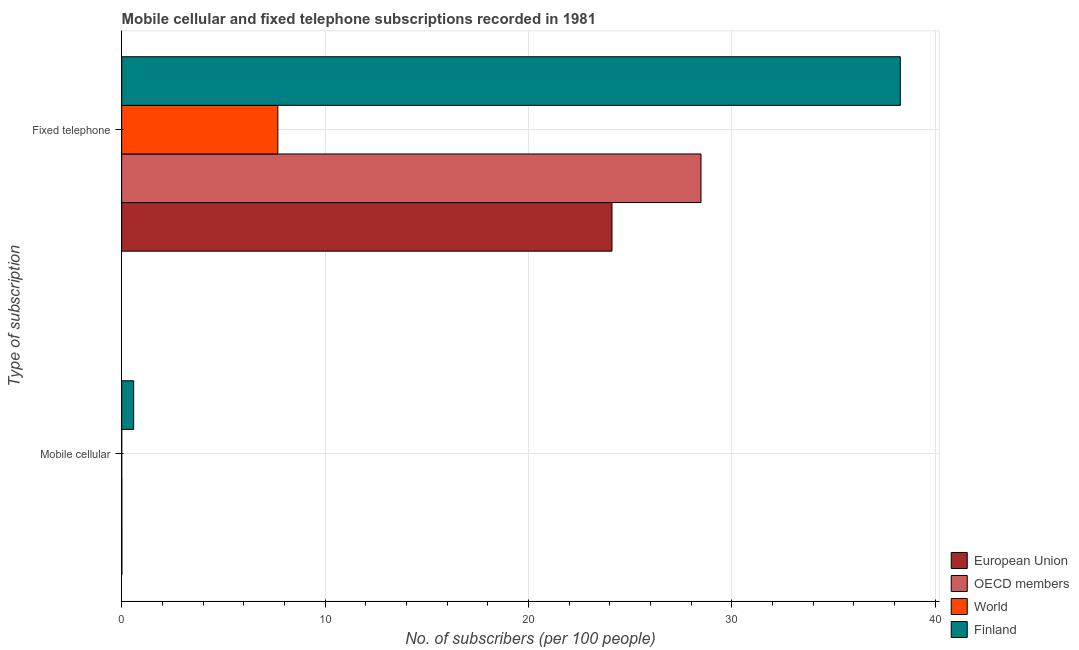How many different coloured bars are there?
Offer a very short reply. 4. Are the number of bars per tick equal to the number of legend labels?
Ensure brevity in your answer.  Yes. How many bars are there on the 2nd tick from the top?
Your answer should be compact. 4. What is the label of the 1st group of bars from the top?
Keep it short and to the point. Fixed telephone. What is the number of mobile cellular subscribers in World?
Your response must be concise. 0. Across all countries, what is the maximum number of fixed telephone subscribers?
Give a very brief answer. 38.28. Across all countries, what is the minimum number of fixed telephone subscribers?
Provide a succinct answer. 7.68. In which country was the number of mobile cellular subscribers minimum?
Your answer should be very brief. World. What is the total number of mobile cellular subscribers in the graph?
Provide a short and direct response. 0.61. What is the difference between the number of mobile cellular subscribers in European Union and that in World?
Offer a very short reply. 0.01. What is the difference between the number of fixed telephone subscribers in World and the number of mobile cellular subscribers in European Union?
Offer a very short reply. 7.67. What is the average number of fixed telephone subscribers per country?
Your answer should be very brief. 24.64. What is the difference between the number of fixed telephone subscribers and number of mobile cellular subscribers in OECD members?
Your response must be concise. 28.48. In how many countries, is the number of fixed telephone subscribers greater than 28 ?
Ensure brevity in your answer.  2. What is the ratio of the number of mobile cellular subscribers in OECD members to that in European Union?
Provide a short and direct response. 0.8. Is the number of mobile cellular subscribers in World less than that in OECD members?
Offer a very short reply. Yes. What does the 1st bar from the bottom in Mobile cellular represents?
Offer a terse response. European Union. What is the difference between two consecutive major ticks on the X-axis?
Give a very brief answer. 10. Does the graph contain any zero values?
Make the answer very short. No. Where does the legend appear in the graph?
Offer a very short reply. Bottom right. How many legend labels are there?
Provide a short and direct response. 4. What is the title of the graph?
Provide a succinct answer. Mobile cellular and fixed telephone subscriptions recorded in 1981. What is the label or title of the X-axis?
Your answer should be very brief. No. of subscribers (per 100 people). What is the label or title of the Y-axis?
Provide a succinct answer. Type of subscription. What is the No. of subscribers (per 100 people) of European Union in Mobile cellular?
Your response must be concise. 0.01. What is the No. of subscribers (per 100 people) of OECD members in Mobile cellular?
Offer a terse response. 0.01. What is the No. of subscribers (per 100 people) of World in Mobile cellular?
Your response must be concise. 0. What is the No. of subscribers (per 100 people) of Finland in Mobile cellular?
Provide a short and direct response. 0.59. What is the No. of subscribers (per 100 people) of European Union in Fixed telephone?
Make the answer very short. 24.11. What is the No. of subscribers (per 100 people) in OECD members in Fixed telephone?
Give a very brief answer. 28.48. What is the No. of subscribers (per 100 people) of World in Fixed telephone?
Provide a succinct answer. 7.68. What is the No. of subscribers (per 100 people) of Finland in Fixed telephone?
Your answer should be compact. 38.28. Across all Type of subscription, what is the maximum No. of subscribers (per 100 people) in European Union?
Your response must be concise. 24.11. Across all Type of subscription, what is the maximum No. of subscribers (per 100 people) in OECD members?
Provide a short and direct response. 28.48. Across all Type of subscription, what is the maximum No. of subscribers (per 100 people) of World?
Your response must be concise. 7.68. Across all Type of subscription, what is the maximum No. of subscribers (per 100 people) of Finland?
Provide a short and direct response. 38.28. Across all Type of subscription, what is the minimum No. of subscribers (per 100 people) of European Union?
Offer a very short reply. 0.01. Across all Type of subscription, what is the minimum No. of subscribers (per 100 people) in OECD members?
Your response must be concise. 0.01. Across all Type of subscription, what is the minimum No. of subscribers (per 100 people) in World?
Offer a terse response. 0. Across all Type of subscription, what is the minimum No. of subscribers (per 100 people) in Finland?
Give a very brief answer. 0.59. What is the total No. of subscribers (per 100 people) of European Union in the graph?
Your response must be concise. 24.12. What is the total No. of subscribers (per 100 people) of OECD members in the graph?
Make the answer very short. 28.49. What is the total No. of subscribers (per 100 people) in World in the graph?
Your response must be concise. 7.68. What is the total No. of subscribers (per 100 people) in Finland in the graph?
Offer a terse response. 38.87. What is the difference between the No. of subscribers (per 100 people) in European Union in Mobile cellular and that in Fixed telephone?
Make the answer very short. -24.1. What is the difference between the No. of subscribers (per 100 people) of OECD members in Mobile cellular and that in Fixed telephone?
Provide a short and direct response. -28.48. What is the difference between the No. of subscribers (per 100 people) in World in Mobile cellular and that in Fixed telephone?
Provide a short and direct response. -7.68. What is the difference between the No. of subscribers (per 100 people) in Finland in Mobile cellular and that in Fixed telephone?
Provide a succinct answer. -37.7. What is the difference between the No. of subscribers (per 100 people) in European Union in Mobile cellular and the No. of subscribers (per 100 people) in OECD members in Fixed telephone?
Provide a short and direct response. -28.47. What is the difference between the No. of subscribers (per 100 people) of European Union in Mobile cellular and the No. of subscribers (per 100 people) of World in Fixed telephone?
Keep it short and to the point. -7.67. What is the difference between the No. of subscribers (per 100 people) of European Union in Mobile cellular and the No. of subscribers (per 100 people) of Finland in Fixed telephone?
Offer a very short reply. -38.27. What is the difference between the No. of subscribers (per 100 people) of OECD members in Mobile cellular and the No. of subscribers (per 100 people) of World in Fixed telephone?
Make the answer very short. -7.67. What is the difference between the No. of subscribers (per 100 people) of OECD members in Mobile cellular and the No. of subscribers (per 100 people) of Finland in Fixed telephone?
Your response must be concise. -38.28. What is the difference between the No. of subscribers (per 100 people) in World in Mobile cellular and the No. of subscribers (per 100 people) in Finland in Fixed telephone?
Offer a terse response. -38.28. What is the average No. of subscribers (per 100 people) in European Union per Type of subscription?
Provide a succinct answer. 12.06. What is the average No. of subscribers (per 100 people) in OECD members per Type of subscription?
Offer a terse response. 14.25. What is the average No. of subscribers (per 100 people) in World per Type of subscription?
Your answer should be compact. 3.84. What is the average No. of subscribers (per 100 people) of Finland per Type of subscription?
Provide a short and direct response. 19.44. What is the difference between the No. of subscribers (per 100 people) in European Union and No. of subscribers (per 100 people) in OECD members in Mobile cellular?
Give a very brief answer. 0. What is the difference between the No. of subscribers (per 100 people) in European Union and No. of subscribers (per 100 people) in World in Mobile cellular?
Your answer should be compact. 0.01. What is the difference between the No. of subscribers (per 100 people) in European Union and No. of subscribers (per 100 people) in Finland in Mobile cellular?
Provide a succinct answer. -0.58. What is the difference between the No. of subscribers (per 100 people) of OECD members and No. of subscribers (per 100 people) of World in Mobile cellular?
Offer a terse response. 0.01. What is the difference between the No. of subscribers (per 100 people) in OECD members and No. of subscribers (per 100 people) in Finland in Mobile cellular?
Offer a terse response. -0.58. What is the difference between the No. of subscribers (per 100 people) of World and No. of subscribers (per 100 people) of Finland in Mobile cellular?
Offer a very short reply. -0.59. What is the difference between the No. of subscribers (per 100 people) of European Union and No. of subscribers (per 100 people) of OECD members in Fixed telephone?
Offer a very short reply. -4.38. What is the difference between the No. of subscribers (per 100 people) of European Union and No. of subscribers (per 100 people) of World in Fixed telephone?
Your answer should be compact. 16.43. What is the difference between the No. of subscribers (per 100 people) in European Union and No. of subscribers (per 100 people) in Finland in Fixed telephone?
Keep it short and to the point. -14.18. What is the difference between the No. of subscribers (per 100 people) in OECD members and No. of subscribers (per 100 people) in World in Fixed telephone?
Offer a very short reply. 20.81. What is the difference between the No. of subscribers (per 100 people) in OECD members and No. of subscribers (per 100 people) in Finland in Fixed telephone?
Keep it short and to the point. -9.8. What is the difference between the No. of subscribers (per 100 people) in World and No. of subscribers (per 100 people) in Finland in Fixed telephone?
Provide a succinct answer. -30.61. What is the ratio of the No. of subscribers (per 100 people) of OECD members in Mobile cellular to that in Fixed telephone?
Offer a very short reply. 0. What is the ratio of the No. of subscribers (per 100 people) of Finland in Mobile cellular to that in Fixed telephone?
Your answer should be very brief. 0.02. What is the difference between the highest and the second highest No. of subscribers (per 100 people) of European Union?
Provide a short and direct response. 24.1. What is the difference between the highest and the second highest No. of subscribers (per 100 people) in OECD members?
Provide a succinct answer. 28.48. What is the difference between the highest and the second highest No. of subscribers (per 100 people) in World?
Keep it short and to the point. 7.68. What is the difference between the highest and the second highest No. of subscribers (per 100 people) of Finland?
Make the answer very short. 37.7. What is the difference between the highest and the lowest No. of subscribers (per 100 people) in European Union?
Ensure brevity in your answer.  24.1. What is the difference between the highest and the lowest No. of subscribers (per 100 people) of OECD members?
Keep it short and to the point. 28.48. What is the difference between the highest and the lowest No. of subscribers (per 100 people) in World?
Your answer should be compact. 7.68. What is the difference between the highest and the lowest No. of subscribers (per 100 people) of Finland?
Make the answer very short. 37.7. 